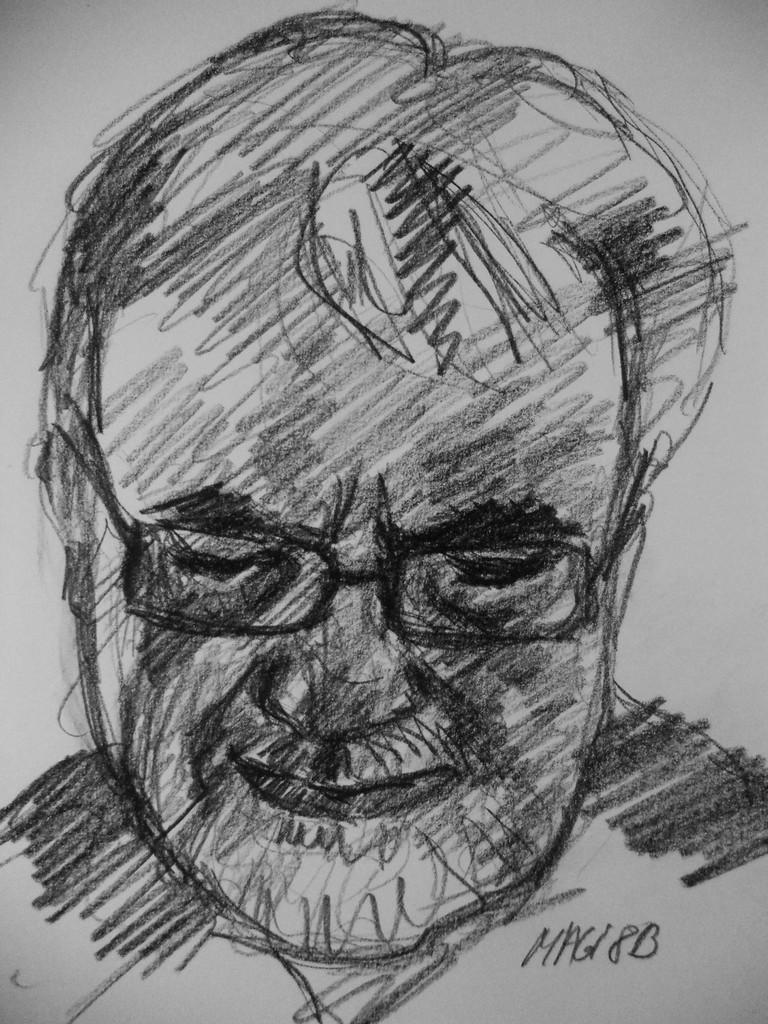Can you describe this image briefly? In this image I can see sketch painting of a man. I can see colour of this painting is black and white. 